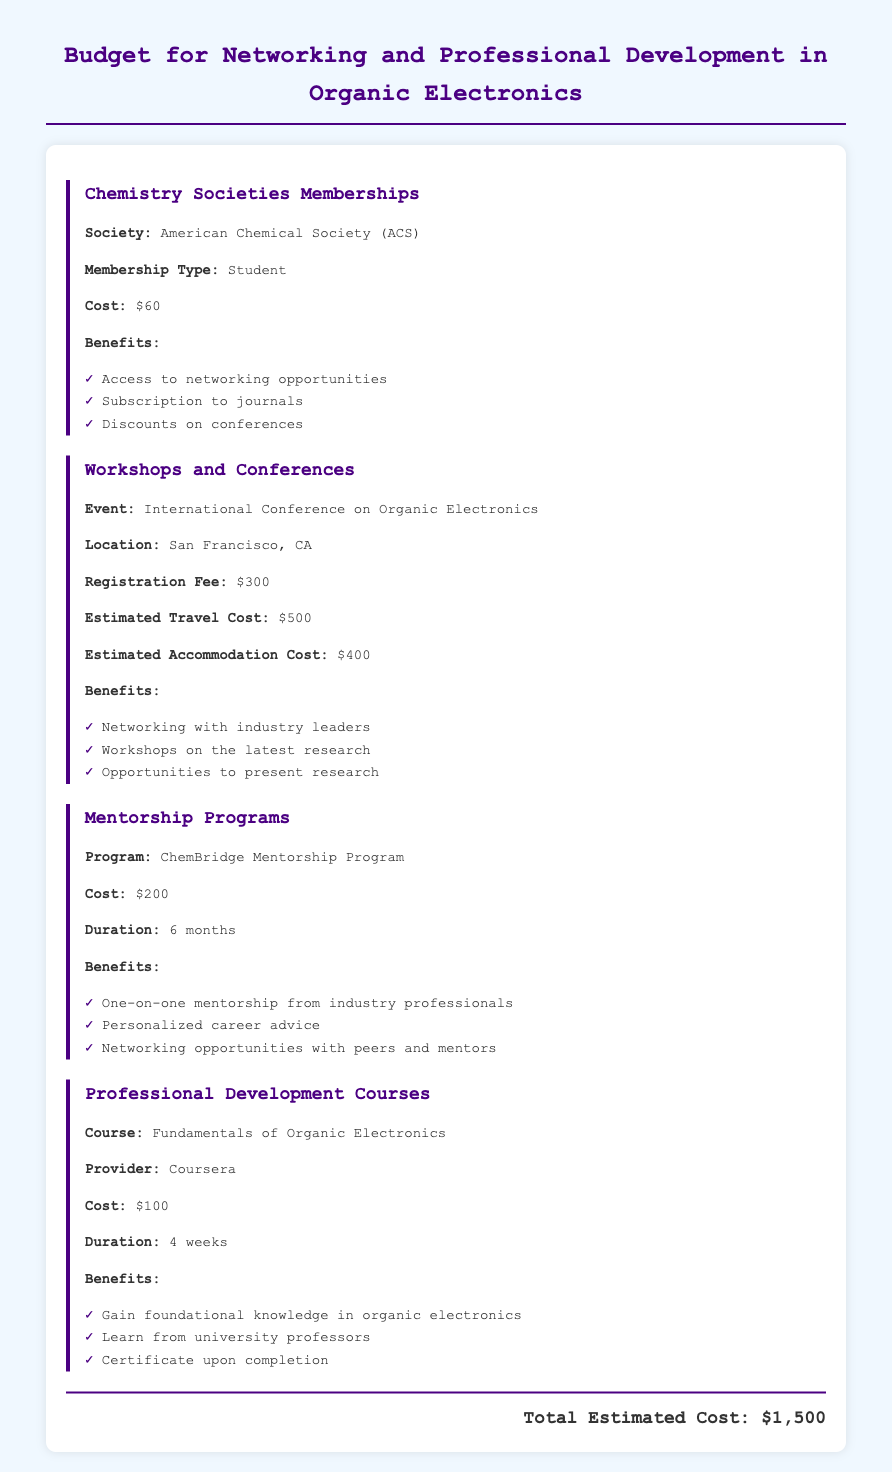What is the membership cost for the American Chemical Society? The cost for the American Chemical Society (ACS) membership is explicitly stated in the document as $60.
Answer: $60 What is the estimated travel cost for the International Conference on Organic Electronics? The estimated travel cost for attending the conference is mentioned as $500.
Answer: $500 How long is the ChemBridge Mentorship Program? The duration of the ChemBridge Mentorship Program is described in the document as 6 months.
Answer: 6 months What is the total estimated cost for all activities listed in the budget? The document provides the total estimated cost, which is $1,500.
Answer: $1,500 What are the benefits of joining the American Chemical Society? The document lists several benefits of ACS membership, including access to networking opportunities, subscription to journals, and discounts on conferences.
Answer: Access to networking opportunities, subscription to journals, discounts on conferences What is the name of the course offered by Coursera in the budget? The document states the course offered by Coursera is titled "Fundamentals of Organic Electronics."
Answer: Fundamentals of Organic Electronics Which event is mentioned for workshops and conferences? The document specifically names the "International Conference on Organic Electronics" as the event for workshops and conferences.
Answer: International Conference on Organic Electronics What is the registration fee for the International Conference on Organic Electronics? The registration fee for the conference is indicated in the document as $300.
Answer: $300 